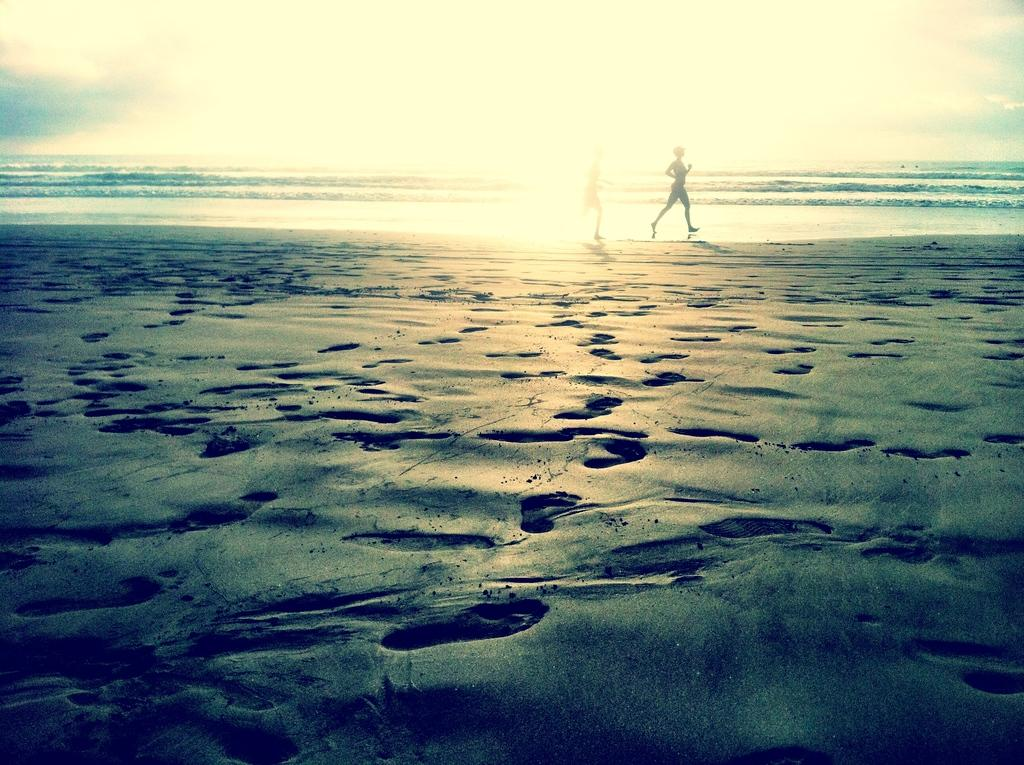What are the two persons in the image doing? The two persons in the image are running. Where are the persons running? The persons are running on the seashore. What evidence of their activity can be seen in the image? There are footprints on the mud in the image. What natural features can be seen in the background of the image? The ocean and the sky are visible in the image. What book is the person reading on the seashore in the image? There is no person reading a book in the image; the two persons are running. What type of waste can be seen on the seashore in the image? There is no waste visible in the image; it only shows the persons running and the footprints on the mud. 